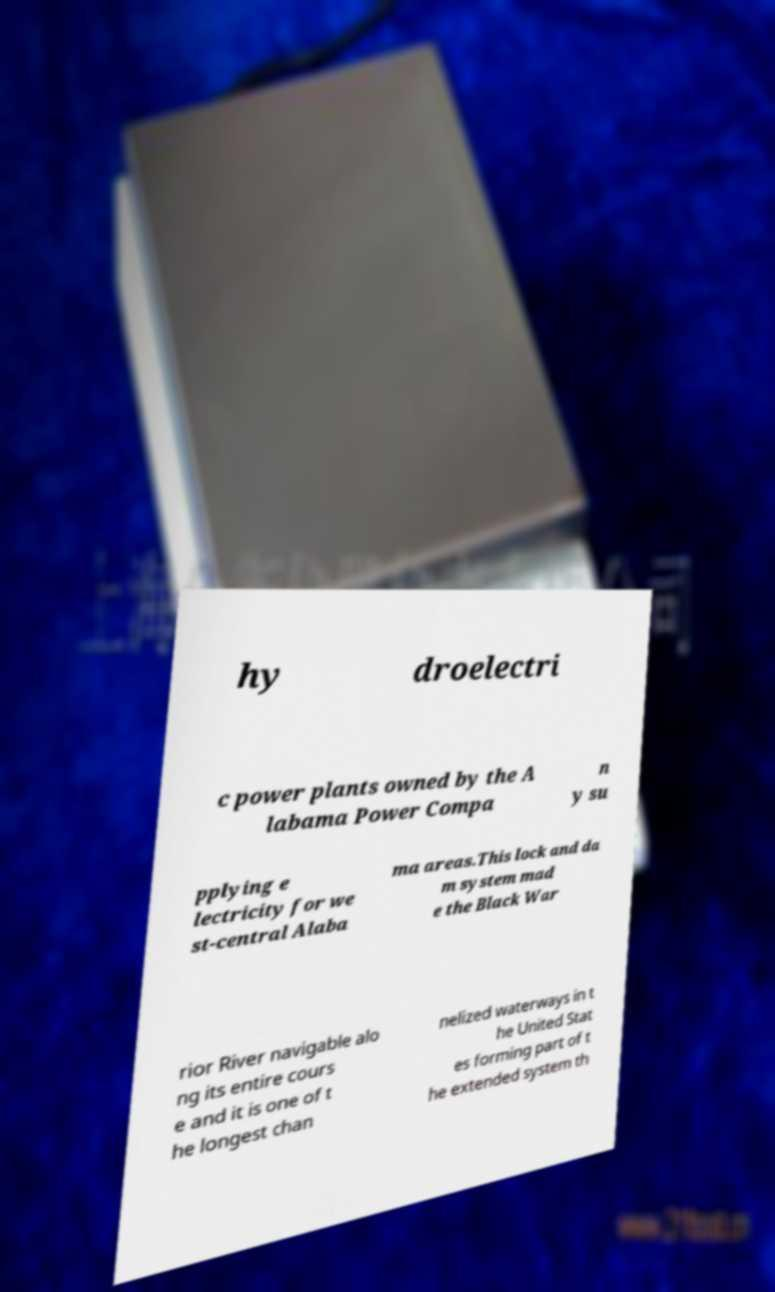Can you read and provide the text displayed in the image?This photo seems to have some interesting text. Can you extract and type it out for me? hy droelectri c power plants owned by the A labama Power Compa n y su pplying e lectricity for we st-central Alaba ma areas.This lock and da m system mad e the Black War rior River navigable alo ng its entire cours e and it is one of t he longest chan nelized waterways in t he United Stat es forming part of t he extended system th 